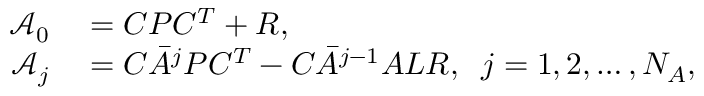Convert formula to latex. <formula><loc_0><loc_0><loc_500><loc_500>\begin{array} { r l } { \mathcal { A } _ { 0 } } & = C P C ^ { T } + R , } \\ { \mathcal { A } _ { j } } & = C \bar { A } ^ { j } P C ^ { T } - C \bar { A } ^ { j - 1 } A L R , \, j = 1 , 2 , \dots , N _ { A } , } \end{array}</formula> 